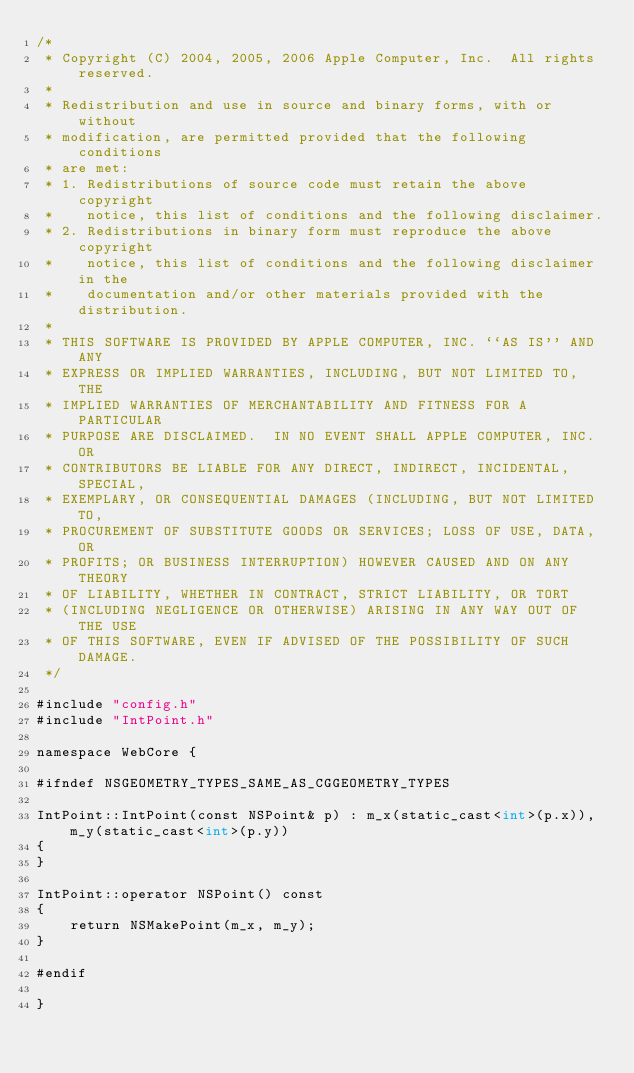Convert code to text. <code><loc_0><loc_0><loc_500><loc_500><_ObjectiveC_>/*
 * Copyright (C) 2004, 2005, 2006 Apple Computer, Inc.  All rights reserved.
 *
 * Redistribution and use in source and binary forms, with or without
 * modification, are permitted provided that the following conditions
 * are met:
 * 1. Redistributions of source code must retain the above copyright
 *    notice, this list of conditions and the following disclaimer.
 * 2. Redistributions in binary form must reproduce the above copyright
 *    notice, this list of conditions and the following disclaimer in the
 *    documentation and/or other materials provided with the distribution.
 *
 * THIS SOFTWARE IS PROVIDED BY APPLE COMPUTER, INC. ``AS IS'' AND ANY
 * EXPRESS OR IMPLIED WARRANTIES, INCLUDING, BUT NOT LIMITED TO, THE
 * IMPLIED WARRANTIES OF MERCHANTABILITY AND FITNESS FOR A PARTICULAR
 * PURPOSE ARE DISCLAIMED.  IN NO EVENT SHALL APPLE COMPUTER, INC. OR
 * CONTRIBUTORS BE LIABLE FOR ANY DIRECT, INDIRECT, INCIDENTAL, SPECIAL,
 * EXEMPLARY, OR CONSEQUENTIAL DAMAGES (INCLUDING, BUT NOT LIMITED TO,
 * PROCUREMENT OF SUBSTITUTE GOODS OR SERVICES; LOSS OF USE, DATA, OR
 * PROFITS; OR BUSINESS INTERRUPTION) HOWEVER CAUSED AND ON ANY THEORY
 * OF LIABILITY, WHETHER IN CONTRACT, STRICT LIABILITY, OR TORT
 * (INCLUDING NEGLIGENCE OR OTHERWISE) ARISING IN ANY WAY OUT OF THE USE
 * OF THIS SOFTWARE, EVEN IF ADVISED OF THE POSSIBILITY OF SUCH DAMAGE. 
 */

#include "config.h"
#include "IntPoint.h"

namespace WebCore {

#ifndef NSGEOMETRY_TYPES_SAME_AS_CGGEOMETRY_TYPES

IntPoint::IntPoint(const NSPoint& p) : m_x(static_cast<int>(p.x)), m_y(static_cast<int>(p.y))
{
}

IntPoint::operator NSPoint() const
{
    return NSMakePoint(m_x, m_y);
}

#endif

}
</code> 